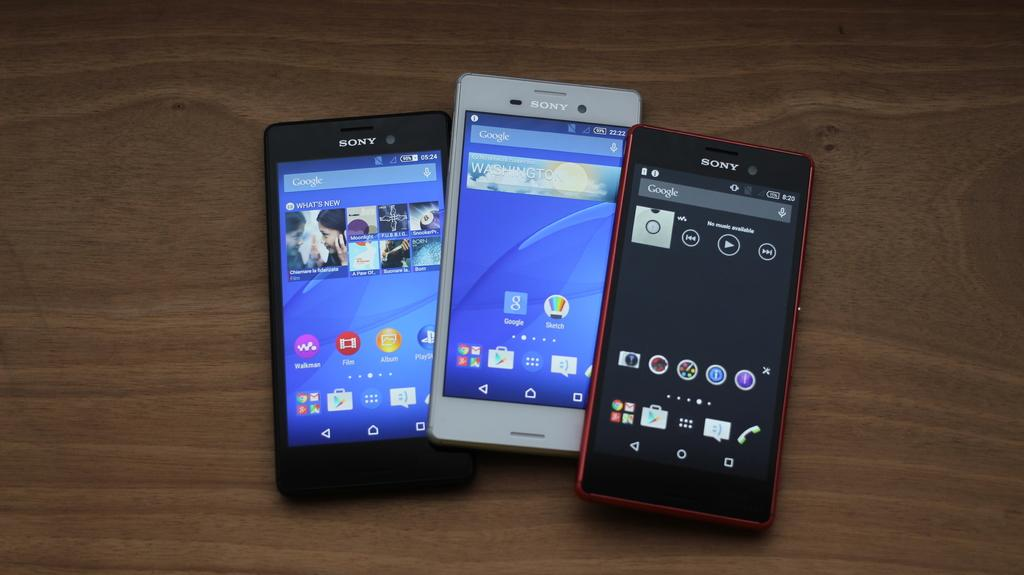<image>
Summarize the visual content of the image. A group of 3 phones all made by the brand Sony. 